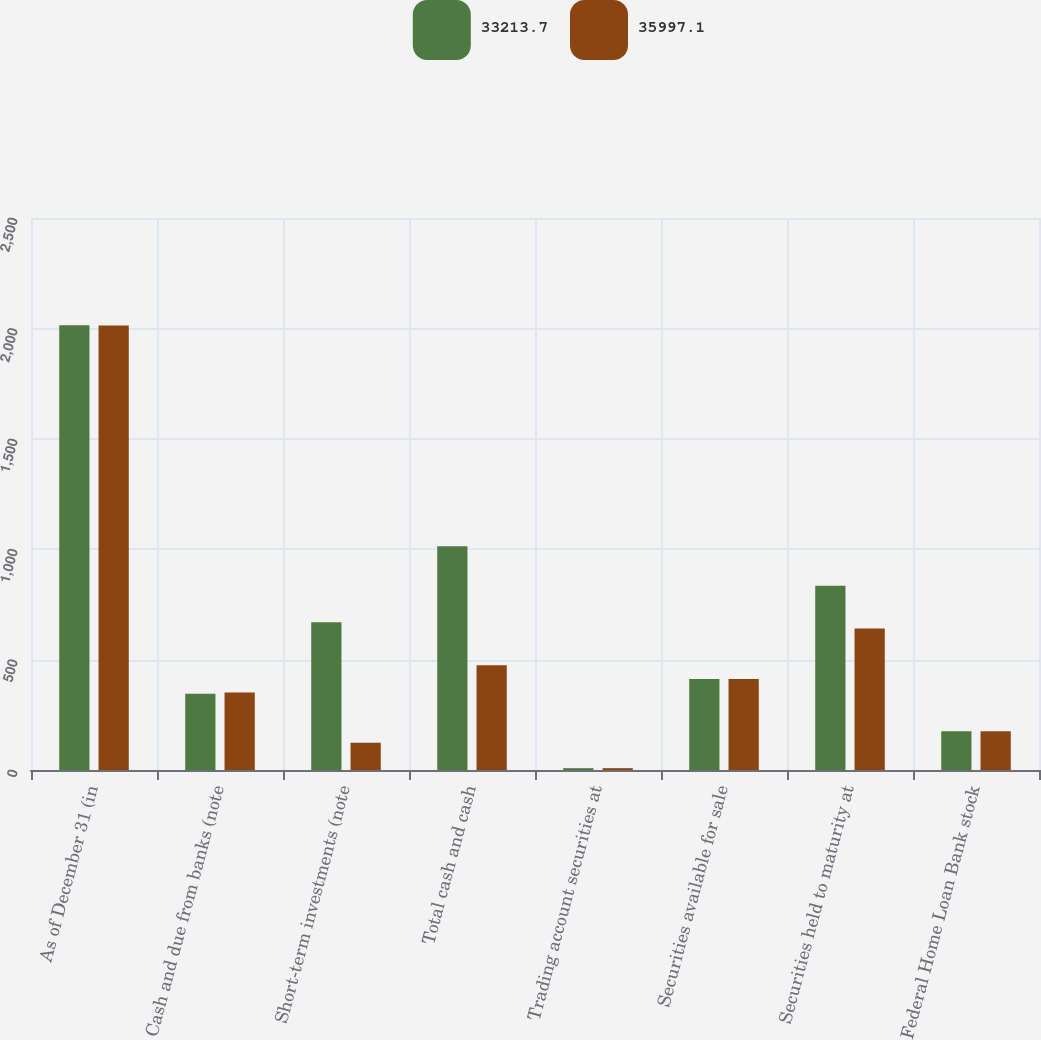<chart> <loc_0><loc_0><loc_500><loc_500><stacked_bar_chart><ecel><fcel>As of December 31 (in<fcel>Cash and due from banks (note<fcel>Short-term investments (note<fcel>Total cash and cash<fcel>Trading account securities at<fcel>Securities available for sale<fcel>Securities held to maturity at<fcel>Federal Home Loan Bank stock<nl><fcel>33213.7<fcel>2014<fcel>345.1<fcel>668.6<fcel>1013.7<fcel>8.3<fcel>412.6<fcel>834.3<fcel>175.7<nl><fcel>35997.1<fcel>2013<fcel>350.8<fcel>123.6<fcel>474.4<fcel>8.3<fcel>412.6<fcel>640.5<fcel>175.7<nl></chart> 